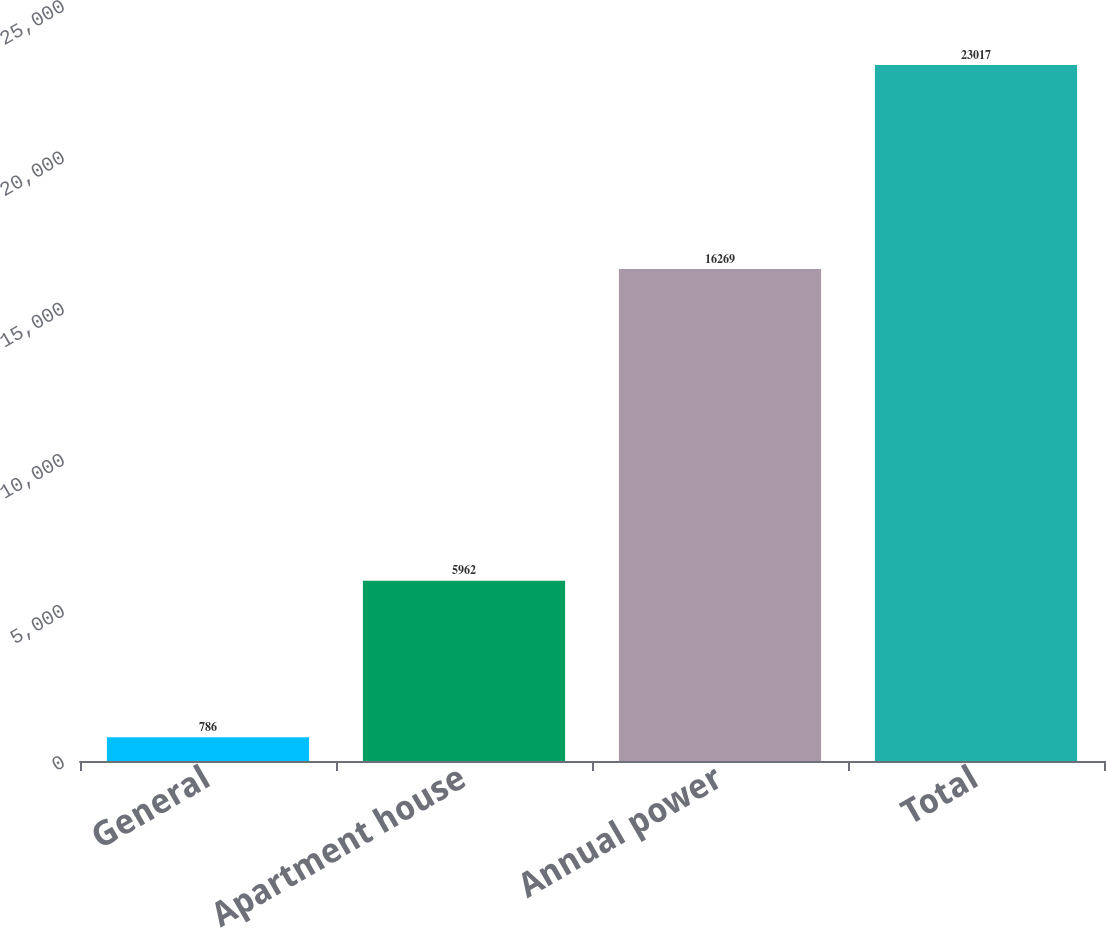Convert chart to OTSL. <chart><loc_0><loc_0><loc_500><loc_500><bar_chart><fcel>General<fcel>Apartment house<fcel>Annual power<fcel>Total<nl><fcel>786<fcel>5962<fcel>16269<fcel>23017<nl></chart> 